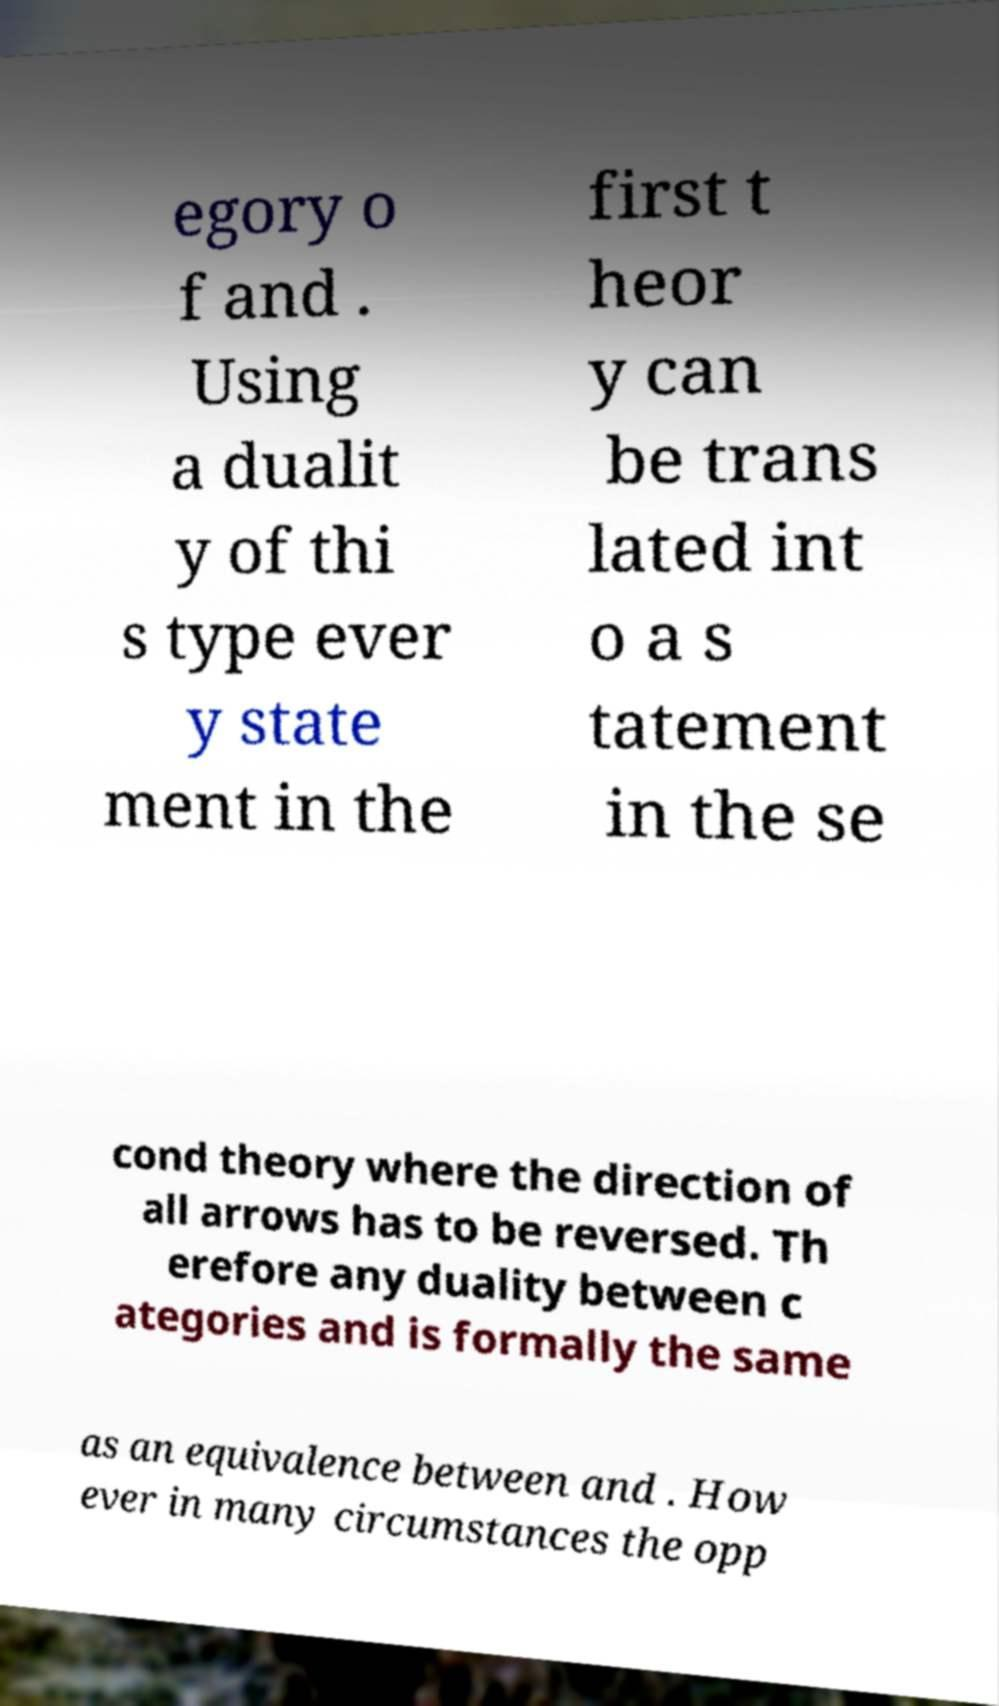What messages or text are displayed in this image? I need them in a readable, typed format. egory o f and . Using a dualit y of thi s type ever y state ment in the first t heor y can be trans lated int o a s tatement in the se cond theory where the direction of all arrows has to be reversed. Th erefore any duality between c ategories and is formally the same as an equivalence between and . How ever in many circumstances the opp 